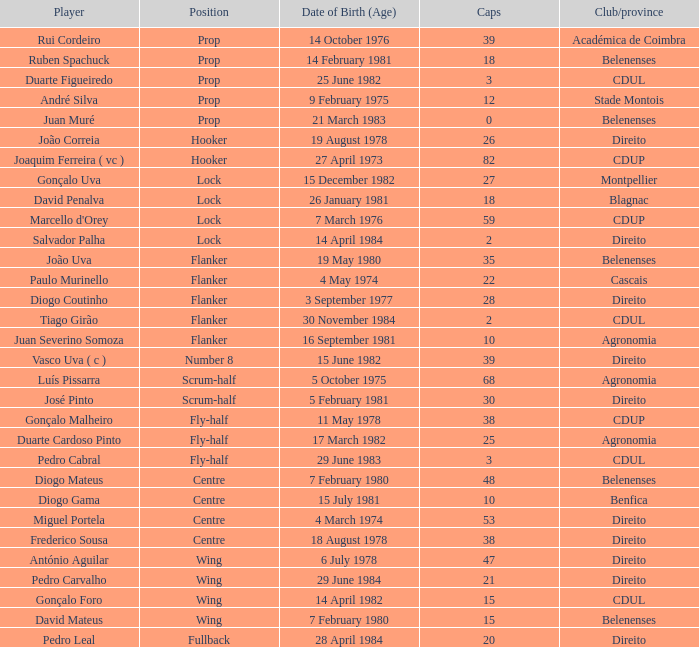Which Club/province has a Player of david penalva? Blagnac. 